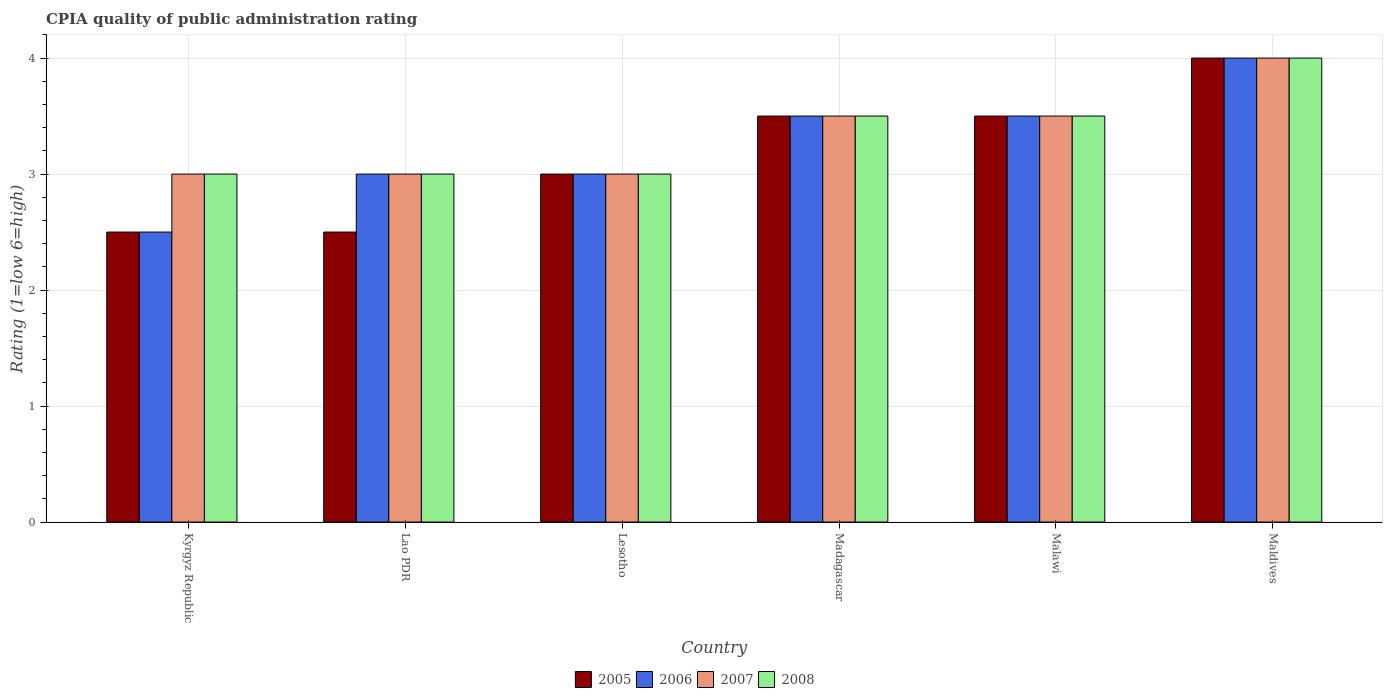How many different coloured bars are there?
Provide a short and direct response. 4. Are the number of bars per tick equal to the number of legend labels?
Give a very brief answer. Yes. Are the number of bars on each tick of the X-axis equal?
Your response must be concise. Yes. How many bars are there on the 3rd tick from the left?
Ensure brevity in your answer.  4. What is the label of the 4th group of bars from the left?
Make the answer very short. Madagascar. In how many cases, is the number of bars for a given country not equal to the number of legend labels?
Your answer should be compact. 0. Across all countries, what is the maximum CPIA rating in 2007?
Offer a very short reply. 4. Across all countries, what is the minimum CPIA rating in 2005?
Ensure brevity in your answer.  2.5. In which country was the CPIA rating in 2007 maximum?
Your response must be concise. Maldives. In which country was the CPIA rating in 2006 minimum?
Offer a terse response. Kyrgyz Republic. What is the difference between the CPIA rating in 2008 in Madagascar and that in Maldives?
Provide a short and direct response. -0.5. What is the difference between the CPIA rating in 2007 in Lesotho and the CPIA rating in 2006 in Kyrgyz Republic?
Your answer should be very brief. 0.5. What is the average CPIA rating in 2008 per country?
Provide a succinct answer. 3.33. In how many countries, is the CPIA rating in 2007 greater than 3.2?
Provide a short and direct response. 3. What is the ratio of the CPIA rating in 2006 in Lesotho to that in Malawi?
Make the answer very short. 0.86. What is the difference between the highest and the lowest CPIA rating in 2007?
Ensure brevity in your answer.  1. In how many countries, is the CPIA rating in 2005 greater than the average CPIA rating in 2005 taken over all countries?
Your answer should be very brief. 3. What does the 2nd bar from the left in Lesotho represents?
Offer a very short reply. 2006. What does the 3rd bar from the right in Malawi represents?
Make the answer very short. 2006. How many bars are there?
Offer a very short reply. 24. Are all the bars in the graph horizontal?
Your response must be concise. No. How many countries are there in the graph?
Offer a very short reply. 6. Does the graph contain grids?
Your response must be concise. Yes. How are the legend labels stacked?
Offer a terse response. Horizontal. What is the title of the graph?
Ensure brevity in your answer.  CPIA quality of public administration rating. What is the label or title of the X-axis?
Your answer should be very brief. Country. What is the label or title of the Y-axis?
Offer a very short reply. Rating (1=low 6=high). What is the Rating (1=low 6=high) in 2005 in Kyrgyz Republic?
Offer a terse response. 2.5. What is the Rating (1=low 6=high) in 2006 in Kyrgyz Republic?
Give a very brief answer. 2.5. What is the Rating (1=low 6=high) in 2005 in Lao PDR?
Your answer should be compact. 2.5. What is the Rating (1=low 6=high) in 2005 in Lesotho?
Ensure brevity in your answer.  3. What is the Rating (1=low 6=high) in 2007 in Lesotho?
Give a very brief answer. 3. What is the Rating (1=low 6=high) of 2005 in Madagascar?
Keep it short and to the point. 3.5. What is the Rating (1=low 6=high) of 2007 in Madagascar?
Offer a terse response. 3.5. What is the Rating (1=low 6=high) of 2008 in Madagascar?
Offer a very short reply. 3.5. What is the Rating (1=low 6=high) in 2005 in Malawi?
Ensure brevity in your answer.  3.5. What is the Rating (1=low 6=high) in 2007 in Malawi?
Keep it short and to the point. 3.5. What is the Rating (1=low 6=high) of 2008 in Malawi?
Provide a short and direct response. 3.5. What is the Rating (1=low 6=high) of 2006 in Maldives?
Provide a short and direct response. 4. What is the Rating (1=low 6=high) in 2008 in Maldives?
Ensure brevity in your answer.  4. Across all countries, what is the maximum Rating (1=low 6=high) of 2005?
Provide a short and direct response. 4. Across all countries, what is the maximum Rating (1=low 6=high) of 2006?
Offer a very short reply. 4. Across all countries, what is the maximum Rating (1=low 6=high) of 2007?
Your answer should be very brief. 4. Across all countries, what is the minimum Rating (1=low 6=high) in 2005?
Your answer should be compact. 2.5. Across all countries, what is the minimum Rating (1=low 6=high) in 2006?
Offer a terse response. 2.5. What is the total Rating (1=low 6=high) of 2005 in the graph?
Provide a short and direct response. 19. What is the total Rating (1=low 6=high) in 2008 in the graph?
Your response must be concise. 20. What is the difference between the Rating (1=low 6=high) in 2005 in Kyrgyz Republic and that in Lao PDR?
Your response must be concise. 0. What is the difference between the Rating (1=low 6=high) of 2006 in Kyrgyz Republic and that in Lao PDR?
Provide a succinct answer. -0.5. What is the difference between the Rating (1=low 6=high) in 2008 in Kyrgyz Republic and that in Lao PDR?
Offer a very short reply. 0. What is the difference between the Rating (1=low 6=high) of 2005 in Kyrgyz Republic and that in Lesotho?
Your answer should be very brief. -0.5. What is the difference between the Rating (1=low 6=high) of 2008 in Kyrgyz Republic and that in Lesotho?
Your answer should be very brief. 0. What is the difference between the Rating (1=low 6=high) of 2005 in Kyrgyz Republic and that in Madagascar?
Ensure brevity in your answer.  -1. What is the difference between the Rating (1=low 6=high) in 2006 in Kyrgyz Republic and that in Madagascar?
Your response must be concise. -1. What is the difference between the Rating (1=low 6=high) of 2008 in Kyrgyz Republic and that in Malawi?
Your answer should be very brief. -0.5. What is the difference between the Rating (1=low 6=high) in 2005 in Kyrgyz Republic and that in Maldives?
Ensure brevity in your answer.  -1.5. What is the difference between the Rating (1=low 6=high) of 2008 in Kyrgyz Republic and that in Maldives?
Keep it short and to the point. -1. What is the difference between the Rating (1=low 6=high) in 2005 in Lao PDR and that in Lesotho?
Ensure brevity in your answer.  -0.5. What is the difference between the Rating (1=low 6=high) of 2007 in Lao PDR and that in Lesotho?
Your response must be concise. 0. What is the difference between the Rating (1=low 6=high) of 2005 in Lao PDR and that in Madagascar?
Your answer should be very brief. -1. What is the difference between the Rating (1=low 6=high) of 2006 in Lao PDR and that in Madagascar?
Offer a terse response. -0.5. What is the difference between the Rating (1=low 6=high) in 2007 in Lao PDR and that in Madagascar?
Keep it short and to the point. -0.5. What is the difference between the Rating (1=low 6=high) of 2008 in Lao PDR and that in Malawi?
Your answer should be compact. -0.5. What is the difference between the Rating (1=low 6=high) of 2005 in Lao PDR and that in Maldives?
Offer a terse response. -1.5. What is the difference between the Rating (1=low 6=high) in 2006 in Lao PDR and that in Maldives?
Your answer should be compact. -1. What is the difference between the Rating (1=low 6=high) in 2008 in Lao PDR and that in Maldives?
Provide a succinct answer. -1. What is the difference between the Rating (1=low 6=high) in 2006 in Lesotho and that in Madagascar?
Your answer should be very brief. -0.5. What is the difference between the Rating (1=low 6=high) of 2008 in Lesotho and that in Madagascar?
Make the answer very short. -0.5. What is the difference between the Rating (1=low 6=high) of 2007 in Lesotho and that in Malawi?
Your answer should be compact. -0.5. What is the difference between the Rating (1=low 6=high) of 2008 in Lesotho and that in Malawi?
Your answer should be compact. -0.5. What is the difference between the Rating (1=low 6=high) in 2005 in Lesotho and that in Maldives?
Your response must be concise. -1. What is the difference between the Rating (1=low 6=high) of 2007 in Lesotho and that in Maldives?
Provide a short and direct response. -1. What is the difference between the Rating (1=low 6=high) of 2007 in Madagascar and that in Malawi?
Offer a terse response. 0. What is the difference between the Rating (1=low 6=high) of 2005 in Madagascar and that in Maldives?
Provide a succinct answer. -0.5. What is the difference between the Rating (1=low 6=high) of 2006 in Madagascar and that in Maldives?
Your answer should be compact. -0.5. What is the difference between the Rating (1=low 6=high) in 2007 in Madagascar and that in Maldives?
Provide a succinct answer. -0.5. What is the difference between the Rating (1=low 6=high) in 2008 in Madagascar and that in Maldives?
Provide a succinct answer. -0.5. What is the difference between the Rating (1=low 6=high) of 2005 in Malawi and that in Maldives?
Offer a terse response. -0.5. What is the difference between the Rating (1=low 6=high) in 2008 in Malawi and that in Maldives?
Offer a very short reply. -0.5. What is the difference between the Rating (1=low 6=high) in 2005 in Kyrgyz Republic and the Rating (1=low 6=high) in 2007 in Lao PDR?
Give a very brief answer. -0.5. What is the difference between the Rating (1=low 6=high) of 2006 in Kyrgyz Republic and the Rating (1=low 6=high) of 2007 in Lao PDR?
Provide a succinct answer. -0.5. What is the difference between the Rating (1=low 6=high) of 2007 in Kyrgyz Republic and the Rating (1=low 6=high) of 2008 in Lao PDR?
Your answer should be very brief. 0. What is the difference between the Rating (1=low 6=high) in 2006 in Kyrgyz Republic and the Rating (1=low 6=high) in 2008 in Lesotho?
Keep it short and to the point. -0.5. What is the difference between the Rating (1=low 6=high) of 2005 in Kyrgyz Republic and the Rating (1=low 6=high) of 2008 in Madagascar?
Provide a short and direct response. -1. What is the difference between the Rating (1=low 6=high) in 2006 in Kyrgyz Republic and the Rating (1=low 6=high) in 2008 in Madagascar?
Provide a succinct answer. -1. What is the difference between the Rating (1=low 6=high) of 2007 in Kyrgyz Republic and the Rating (1=low 6=high) of 2008 in Madagascar?
Keep it short and to the point. -0.5. What is the difference between the Rating (1=low 6=high) of 2006 in Kyrgyz Republic and the Rating (1=low 6=high) of 2007 in Malawi?
Your answer should be compact. -1. What is the difference between the Rating (1=low 6=high) of 2006 in Kyrgyz Republic and the Rating (1=low 6=high) of 2008 in Malawi?
Make the answer very short. -1. What is the difference between the Rating (1=low 6=high) of 2007 in Kyrgyz Republic and the Rating (1=low 6=high) of 2008 in Malawi?
Your answer should be very brief. -0.5. What is the difference between the Rating (1=low 6=high) of 2005 in Kyrgyz Republic and the Rating (1=low 6=high) of 2006 in Maldives?
Provide a succinct answer. -1.5. What is the difference between the Rating (1=low 6=high) in 2005 in Kyrgyz Republic and the Rating (1=low 6=high) in 2008 in Maldives?
Your response must be concise. -1.5. What is the difference between the Rating (1=low 6=high) of 2006 in Kyrgyz Republic and the Rating (1=low 6=high) of 2007 in Maldives?
Your response must be concise. -1.5. What is the difference between the Rating (1=low 6=high) in 2006 in Kyrgyz Republic and the Rating (1=low 6=high) in 2008 in Maldives?
Your answer should be very brief. -1.5. What is the difference between the Rating (1=low 6=high) of 2005 in Lao PDR and the Rating (1=low 6=high) of 2006 in Lesotho?
Your answer should be very brief. -0.5. What is the difference between the Rating (1=low 6=high) in 2005 in Lao PDR and the Rating (1=low 6=high) in 2007 in Lesotho?
Give a very brief answer. -0.5. What is the difference between the Rating (1=low 6=high) of 2005 in Lao PDR and the Rating (1=low 6=high) of 2008 in Lesotho?
Provide a short and direct response. -0.5. What is the difference between the Rating (1=low 6=high) in 2006 in Lao PDR and the Rating (1=low 6=high) in 2008 in Lesotho?
Offer a very short reply. 0. What is the difference between the Rating (1=low 6=high) of 2005 in Lao PDR and the Rating (1=low 6=high) of 2008 in Madagascar?
Your answer should be very brief. -1. What is the difference between the Rating (1=low 6=high) in 2006 in Lao PDR and the Rating (1=low 6=high) in 2008 in Madagascar?
Offer a terse response. -0.5. What is the difference between the Rating (1=low 6=high) of 2007 in Lao PDR and the Rating (1=low 6=high) of 2008 in Madagascar?
Your answer should be very brief. -0.5. What is the difference between the Rating (1=low 6=high) in 2005 in Lao PDR and the Rating (1=low 6=high) in 2007 in Malawi?
Give a very brief answer. -1. What is the difference between the Rating (1=low 6=high) of 2006 in Lao PDR and the Rating (1=low 6=high) of 2007 in Malawi?
Provide a succinct answer. -0.5. What is the difference between the Rating (1=low 6=high) in 2005 in Lao PDR and the Rating (1=low 6=high) in 2006 in Maldives?
Make the answer very short. -1.5. What is the difference between the Rating (1=low 6=high) in 2006 in Lao PDR and the Rating (1=low 6=high) in 2008 in Maldives?
Ensure brevity in your answer.  -1. What is the difference between the Rating (1=low 6=high) of 2007 in Lao PDR and the Rating (1=low 6=high) of 2008 in Maldives?
Offer a very short reply. -1. What is the difference between the Rating (1=low 6=high) in 2005 in Lesotho and the Rating (1=low 6=high) in 2006 in Madagascar?
Make the answer very short. -0.5. What is the difference between the Rating (1=low 6=high) in 2005 in Lesotho and the Rating (1=low 6=high) in 2008 in Madagascar?
Offer a terse response. -0.5. What is the difference between the Rating (1=low 6=high) in 2006 in Lesotho and the Rating (1=low 6=high) in 2007 in Madagascar?
Give a very brief answer. -0.5. What is the difference between the Rating (1=low 6=high) in 2005 in Lesotho and the Rating (1=low 6=high) in 2006 in Malawi?
Offer a terse response. -0.5. What is the difference between the Rating (1=low 6=high) of 2005 in Lesotho and the Rating (1=low 6=high) of 2008 in Malawi?
Keep it short and to the point. -0.5. What is the difference between the Rating (1=low 6=high) of 2006 in Lesotho and the Rating (1=low 6=high) of 2008 in Malawi?
Offer a very short reply. -0.5. What is the difference between the Rating (1=low 6=high) of 2005 in Lesotho and the Rating (1=low 6=high) of 2006 in Maldives?
Your answer should be compact. -1. What is the difference between the Rating (1=low 6=high) in 2005 in Madagascar and the Rating (1=low 6=high) in 2007 in Malawi?
Provide a short and direct response. 0. What is the difference between the Rating (1=low 6=high) of 2005 in Madagascar and the Rating (1=low 6=high) of 2006 in Maldives?
Offer a terse response. -0.5. What is the difference between the Rating (1=low 6=high) in 2007 in Madagascar and the Rating (1=low 6=high) in 2008 in Maldives?
Offer a terse response. -0.5. What is the difference between the Rating (1=low 6=high) in 2006 in Malawi and the Rating (1=low 6=high) in 2007 in Maldives?
Offer a very short reply. -0.5. What is the average Rating (1=low 6=high) of 2005 per country?
Give a very brief answer. 3.17. What is the average Rating (1=low 6=high) of 2007 per country?
Keep it short and to the point. 3.33. What is the average Rating (1=low 6=high) of 2008 per country?
Offer a terse response. 3.33. What is the difference between the Rating (1=low 6=high) in 2005 and Rating (1=low 6=high) in 2006 in Kyrgyz Republic?
Provide a succinct answer. 0. What is the difference between the Rating (1=low 6=high) of 2007 and Rating (1=low 6=high) of 2008 in Kyrgyz Republic?
Your response must be concise. 0. What is the difference between the Rating (1=low 6=high) in 2005 and Rating (1=low 6=high) in 2006 in Lao PDR?
Provide a short and direct response. -0.5. What is the difference between the Rating (1=low 6=high) in 2006 and Rating (1=low 6=high) in 2008 in Lao PDR?
Provide a succinct answer. 0. What is the difference between the Rating (1=low 6=high) in 2007 and Rating (1=low 6=high) in 2008 in Lao PDR?
Ensure brevity in your answer.  0. What is the difference between the Rating (1=low 6=high) of 2005 and Rating (1=low 6=high) of 2008 in Lesotho?
Make the answer very short. 0. What is the difference between the Rating (1=low 6=high) in 2007 and Rating (1=low 6=high) in 2008 in Lesotho?
Provide a short and direct response. 0. What is the difference between the Rating (1=low 6=high) in 2005 and Rating (1=low 6=high) in 2006 in Madagascar?
Provide a short and direct response. 0. What is the difference between the Rating (1=low 6=high) of 2006 and Rating (1=low 6=high) of 2008 in Madagascar?
Make the answer very short. 0. What is the difference between the Rating (1=low 6=high) of 2005 and Rating (1=low 6=high) of 2007 in Malawi?
Keep it short and to the point. 0. What is the difference between the Rating (1=low 6=high) in 2006 and Rating (1=low 6=high) in 2007 in Malawi?
Keep it short and to the point. 0. What is the difference between the Rating (1=low 6=high) in 2006 and Rating (1=low 6=high) in 2008 in Malawi?
Provide a short and direct response. 0. What is the difference between the Rating (1=low 6=high) of 2005 and Rating (1=low 6=high) of 2006 in Maldives?
Give a very brief answer. 0. What is the difference between the Rating (1=low 6=high) of 2005 and Rating (1=low 6=high) of 2007 in Maldives?
Provide a succinct answer. 0. What is the difference between the Rating (1=low 6=high) of 2006 and Rating (1=low 6=high) of 2007 in Maldives?
Offer a terse response. 0. What is the difference between the Rating (1=low 6=high) of 2006 and Rating (1=low 6=high) of 2008 in Maldives?
Your answer should be very brief. 0. What is the difference between the Rating (1=low 6=high) in 2007 and Rating (1=low 6=high) in 2008 in Maldives?
Your answer should be compact. 0. What is the ratio of the Rating (1=low 6=high) in 2005 in Kyrgyz Republic to that in Lao PDR?
Offer a very short reply. 1. What is the ratio of the Rating (1=low 6=high) of 2006 in Kyrgyz Republic to that in Lao PDR?
Ensure brevity in your answer.  0.83. What is the ratio of the Rating (1=low 6=high) in 2007 in Kyrgyz Republic to that in Lao PDR?
Offer a terse response. 1. What is the ratio of the Rating (1=low 6=high) in 2008 in Kyrgyz Republic to that in Lao PDR?
Your answer should be compact. 1. What is the ratio of the Rating (1=low 6=high) of 2006 in Kyrgyz Republic to that in Lesotho?
Your response must be concise. 0.83. What is the ratio of the Rating (1=low 6=high) in 2005 in Kyrgyz Republic to that in Madagascar?
Make the answer very short. 0.71. What is the ratio of the Rating (1=low 6=high) in 2006 in Kyrgyz Republic to that in Madagascar?
Give a very brief answer. 0.71. What is the ratio of the Rating (1=low 6=high) in 2007 in Kyrgyz Republic to that in Madagascar?
Keep it short and to the point. 0.86. What is the ratio of the Rating (1=low 6=high) in 2005 in Kyrgyz Republic to that in Malawi?
Your answer should be very brief. 0.71. What is the ratio of the Rating (1=low 6=high) of 2006 in Kyrgyz Republic to that in Malawi?
Offer a very short reply. 0.71. What is the ratio of the Rating (1=low 6=high) in 2007 in Kyrgyz Republic to that in Malawi?
Make the answer very short. 0.86. What is the ratio of the Rating (1=low 6=high) in 2008 in Kyrgyz Republic to that in Malawi?
Provide a succinct answer. 0.86. What is the ratio of the Rating (1=low 6=high) of 2006 in Kyrgyz Republic to that in Maldives?
Make the answer very short. 0.62. What is the ratio of the Rating (1=low 6=high) in 2008 in Kyrgyz Republic to that in Maldives?
Make the answer very short. 0.75. What is the ratio of the Rating (1=low 6=high) in 2006 in Lao PDR to that in Lesotho?
Your answer should be compact. 1. What is the ratio of the Rating (1=low 6=high) of 2005 in Lao PDR to that in Madagascar?
Your response must be concise. 0.71. What is the ratio of the Rating (1=low 6=high) in 2006 in Lao PDR to that in Madagascar?
Keep it short and to the point. 0.86. What is the ratio of the Rating (1=low 6=high) in 2005 in Lao PDR to that in Malawi?
Offer a terse response. 0.71. What is the ratio of the Rating (1=low 6=high) in 2007 in Lao PDR to that in Malawi?
Make the answer very short. 0.86. What is the ratio of the Rating (1=low 6=high) of 2008 in Lao PDR to that in Malawi?
Keep it short and to the point. 0.86. What is the ratio of the Rating (1=low 6=high) in 2005 in Lao PDR to that in Maldives?
Give a very brief answer. 0.62. What is the ratio of the Rating (1=low 6=high) in 2006 in Lao PDR to that in Maldives?
Your answer should be compact. 0.75. What is the ratio of the Rating (1=low 6=high) in 2007 in Lao PDR to that in Maldives?
Ensure brevity in your answer.  0.75. What is the ratio of the Rating (1=low 6=high) in 2005 in Lesotho to that in Madagascar?
Offer a very short reply. 0.86. What is the ratio of the Rating (1=low 6=high) of 2006 in Lesotho to that in Madagascar?
Make the answer very short. 0.86. What is the ratio of the Rating (1=low 6=high) of 2006 in Lesotho to that in Malawi?
Give a very brief answer. 0.86. What is the ratio of the Rating (1=low 6=high) in 2007 in Lesotho to that in Malawi?
Offer a terse response. 0.86. What is the ratio of the Rating (1=low 6=high) in 2008 in Lesotho to that in Malawi?
Offer a very short reply. 0.86. What is the ratio of the Rating (1=low 6=high) in 2006 in Lesotho to that in Maldives?
Give a very brief answer. 0.75. What is the ratio of the Rating (1=low 6=high) of 2007 in Lesotho to that in Maldives?
Provide a short and direct response. 0.75. What is the ratio of the Rating (1=low 6=high) of 2008 in Madagascar to that in Malawi?
Offer a terse response. 1. What is the ratio of the Rating (1=low 6=high) in 2006 in Malawi to that in Maldives?
Provide a succinct answer. 0.88. What is the ratio of the Rating (1=low 6=high) of 2007 in Malawi to that in Maldives?
Keep it short and to the point. 0.88. What is the difference between the highest and the second highest Rating (1=low 6=high) in 2005?
Your answer should be very brief. 0.5. What is the difference between the highest and the second highest Rating (1=low 6=high) in 2007?
Keep it short and to the point. 0.5. What is the difference between the highest and the lowest Rating (1=low 6=high) of 2006?
Provide a succinct answer. 1.5. What is the difference between the highest and the lowest Rating (1=low 6=high) of 2007?
Make the answer very short. 1. What is the difference between the highest and the lowest Rating (1=low 6=high) in 2008?
Provide a succinct answer. 1. 